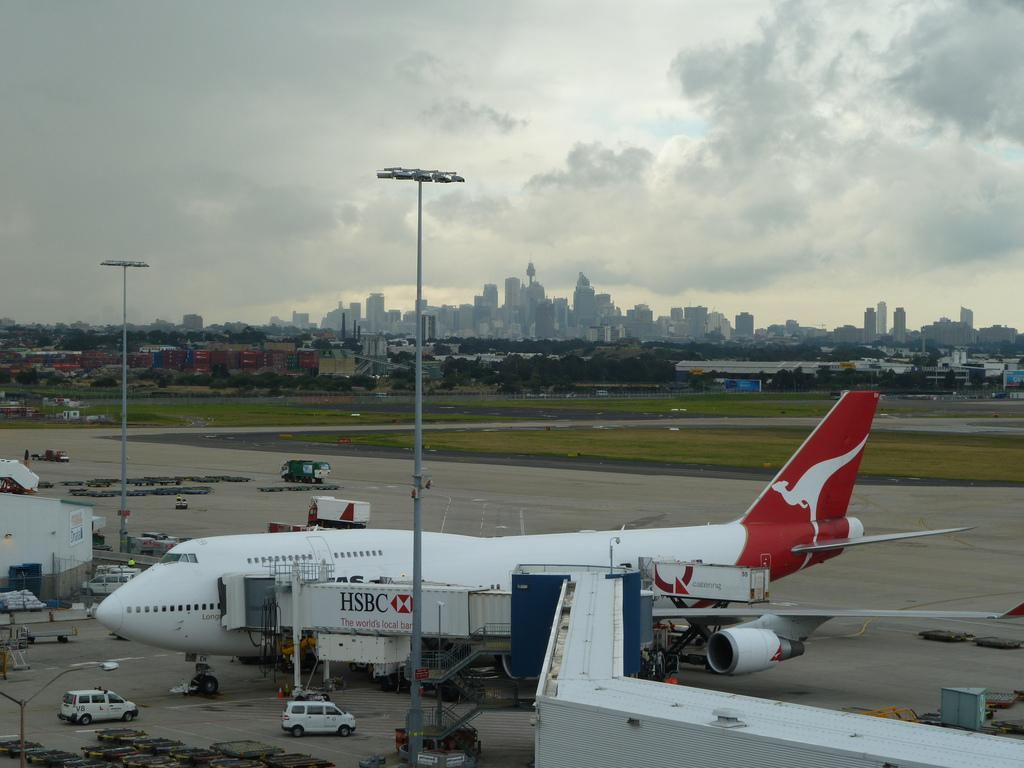Question: how is the weather like?
Choices:
A. Cloudy.
B. Sunny.
C. Foggy.
D. Rainy.
Answer with the letter. Answer: A Question: what has a white kangaroo logo?
Choices:
A. The zoo.
B. The grocery store.
C. The bus company.
D. Red tail.
Answer with the letter. Answer: D Question: what has an hsbc logo on it?
Choices:
A. Airplane.
B. Walkway.
C. Bus.
D. Van.
Answer with the letter. Answer: B Question: what is the transportation name?
Choices:
A. Airplane.
B. Cab.
C. Bus.
D. Train.
Answer with the letter. Answer: A Question: how many light poles are there?
Choices:
A. 2.
B. 1.
C. 3.
D. 4.
Answer with the letter. Answer: A Question: what type of day is it?
Choices:
A. Bright.
B. Clear.
C. Cloudy.
D. Sunny.
Answer with the letter. Answer: C Question: where are lights?
Choices:
A. On the Christmas tree.
B. Over plane.
C. In the ceiling.
D. On the front of the car.
Answer with the letter. Answer: B Question: what has a red tail?
Choices:
A. Plane.
B. Kite.
C. Helicopter.
D. Balloon.
Answer with the letter. Answer: A Question: what does the plane have on the tail?
Choices:
A. Kangaroo image.
B. Clouds.
C. Stars.
D. United States.
Answer with the letter. Answer: A Question: what does the gate to the plane say?
Choices:
A. Bank of America.
B. Hsbc.
C. Welcome.
D. Farewell.
Answer with the letter. Answer: B Question: where is it?
Choices:
A. Train station.
B. Airport.
C. Subway Station.
D. Bus Stop.
Answer with the letter. Answer: B Question: how is the sky?
Choices:
A. Very cloudy.
B. Clear.
C. Filled with a thunderstorm.
D. Blue with little wisps of clouds.
Answer with the letter. Answer: A Question: where was the picture taken?
Choices:
A. At an airport.
B. Train station.
C. Bus station.
D. Subway.
Answer with the letter. Answer: A Question: what are those structures in the distance?
Choices:
A. Hills.
B. Trees.
C. Buildings.
D. Sunsets.
Answer with the letter. Answer: C Question: what direction is the plane facing?
Choices:
A. Right.
B. South.
C. East.
D. Left.
Answer with the letter. Answer: D Question: how would you describe the type of day?
Choices:
A. Sunny.
B. Snowy.
C. Sad.
D. Overcast.
Answer with the letter. Answer: D Question: how many white vehicles are in the picture?
Choices:
A. 2.
B. 1.
C. 3.
D. 4.
Answer with the letter. Answer: A 